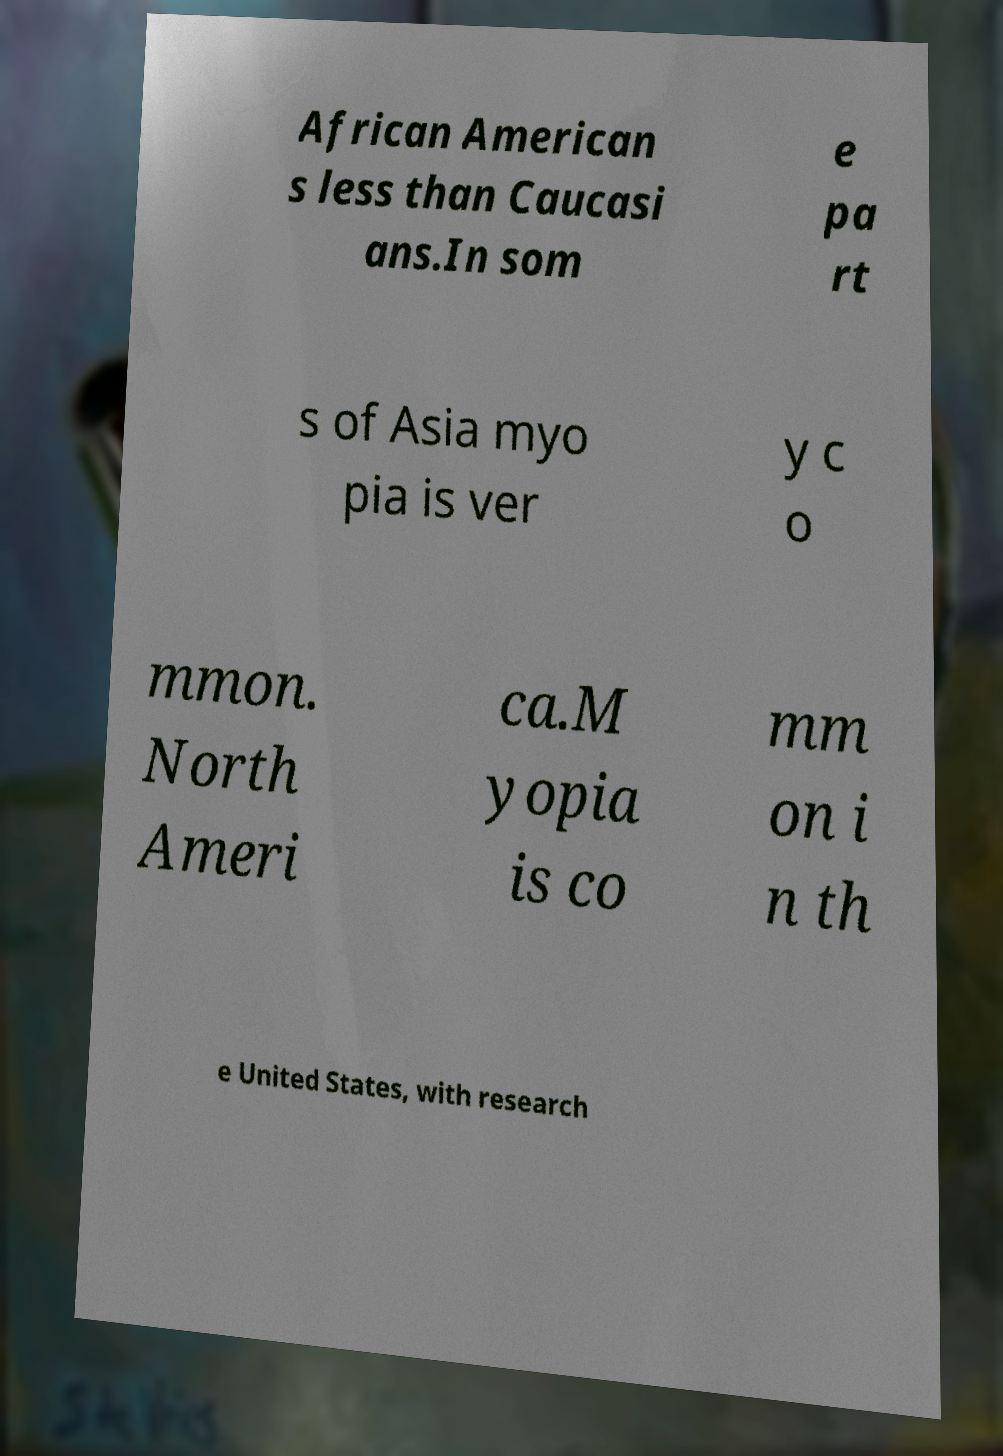Can you accurately transcribe the text from the provided image for me? African American s less than Caucasi ans.In som e pa rt s of Asia myo pia is ver y c o mmon. North Ameri ca.M yopia is co mm on i n th e United States, with research 